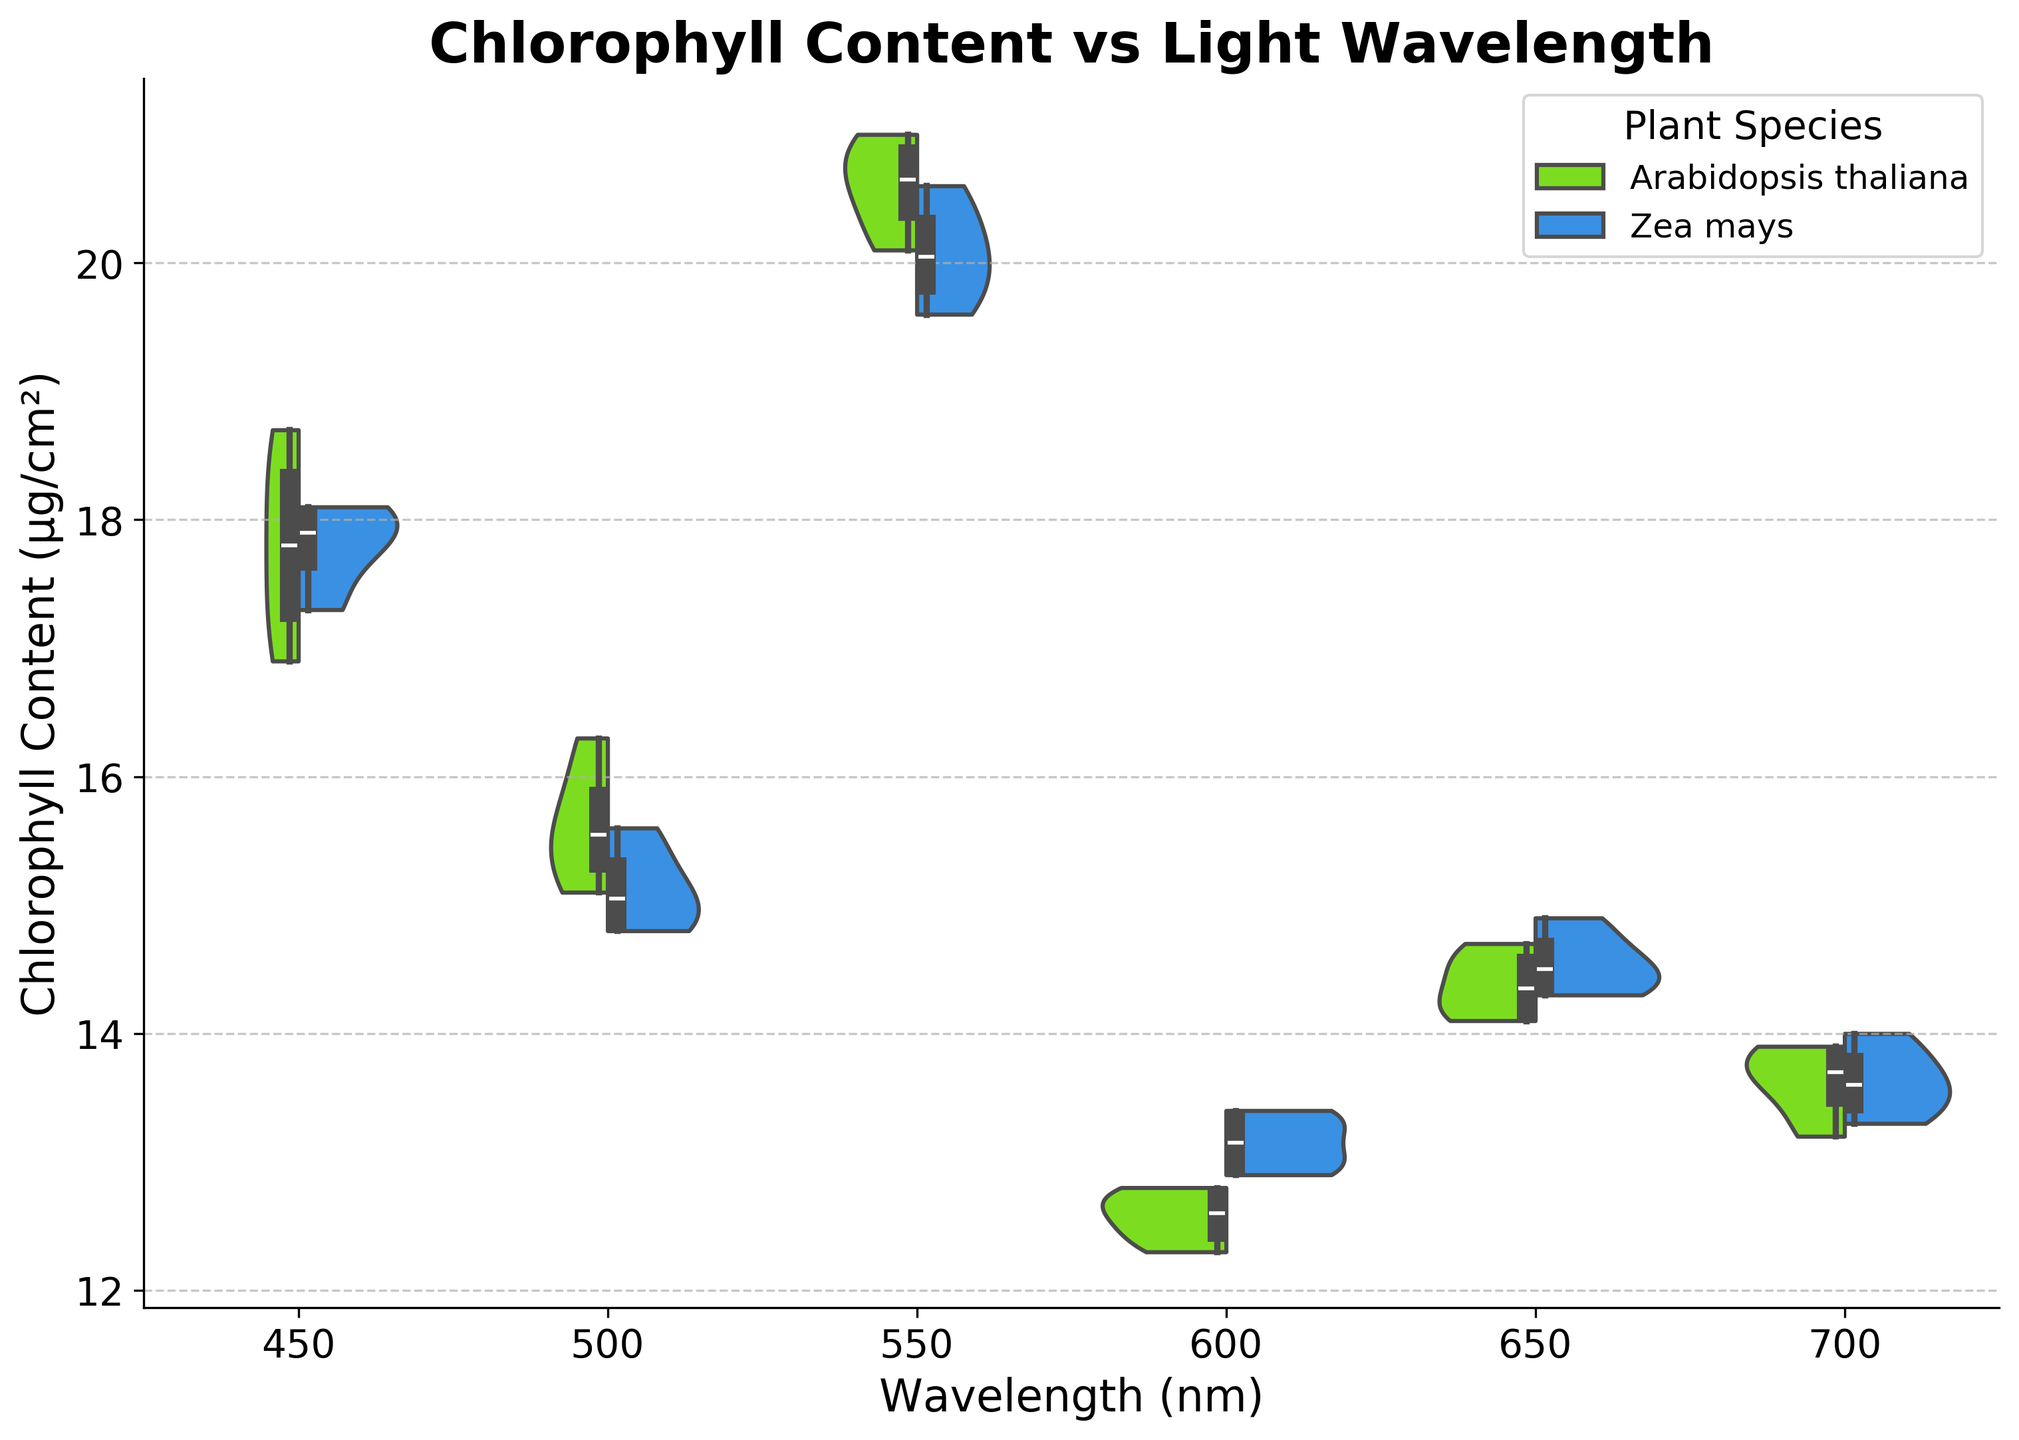What's the median chlorophyll content for Arabidopsis thaliana under 450 nm wavelength? To find the median, look for the box plot within the violin plot for Arabidopsis thaliana under the 450 nm wavelength. The line inside the box indicates the median.
Answer: 17.8 µg/cm² Which plant species has the more significant variation in chlorophyll content at 500 nm wavelength? Greater variation in chlorophyll content is represented by a wider violin plot. Visually compare the widths of Arabidopsis thaliana and Zea mays at 500 nm. Arabidopsis thaliana shows a wider distribution.
Answer: Arabidopsis thaliana What's the average chlorophyll content for Zea mays under 650 nm wavelength? For Zea mays at 650 nm, the content values are 14.3, 14.9, 14.4, and 14.6 µg/cm². Sum these values (14.3 + 14.9 + 14.4 + 14.6 = 58.2) and then divide by the total number of values (58.2 / 4).
Answer: 14.55 µg/cm² How does the median chlorophyll content for Zea mays compare between 600 nm and 700 nm wavelengths? The median is the line inside the box in the box plot. Compare the median value for Zea mays at 600 nm and 700 nm. The medians are very close visually.
Answer: Nearly equal At which wavelength does Arabidopsis thaliana have the highest spread in chlorophyll content? The spread is indicated by the overall width of the violin plot. Look for the widest violins for Arabidopsis thaliana across all wavelengths. 550 nm shows the widest spread.
Answer: 550 nm What is the overall trend in chlorophyll content of Arabidopsis thaliana as the wavelength increases from 450 nm to 700 nm? Examine the median values inside the box plots of Arabidopsis thaliana from 450 nm to 700 nm to identify a pattern or trend. The content increases up to 550 nm and then decreases.
Answer: Increases then decreases Which wavelength shows the smallest difference in median chlorophyll content between Arabidopsis thaliana and Zea mays? The smallest difference is where the medians (middle lines of the box plots) for both plants are closest. Compare each wavelength's median for both species.
Answer: 700 nm Which plant species shows less variation in chlorophyll content at 600 nm wavelength? Variation is represented by the width of the violin plot. Compare the widths for both species at 600 nm.
Answer: Arabidopsis thaliana What does the title of the plot indicate about the relationship being studied? The title provides a summary of the plot content. It specifies the relationship between chlorophyll content and light wavelength.
Answer: Chlorophyll Content vs Light Wavelength 